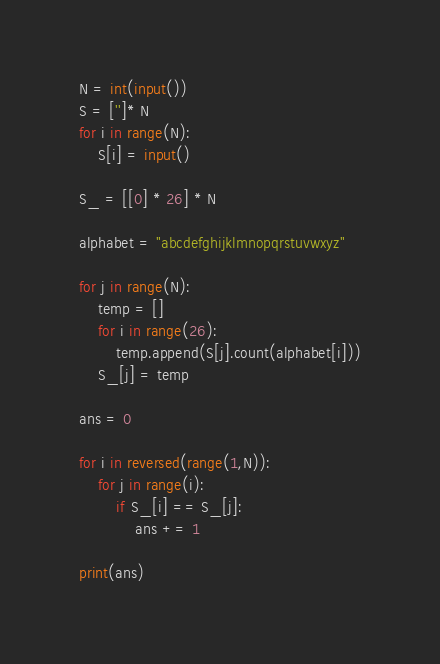<code> <loc_0><loc_0><loc_500><loc_500><_Python_>N = int(input())
S = ['']* N
for i in range(N):
    S[i] = input()

S_ = [[0] * 26] * N

alphabet = "abcdefghijklmnopqrstuvwxyz"

for j in range(N):
    temp = []
    for i in range(26):
        temp.append(S[j].count(alphabet[i]))
    S_[j] = temp

ans = 0

for i in reversed(range(1,N)):
    for j in range(i):
        if S_[i] == S_[j]:
            ans += 1

print(ans)</code> 